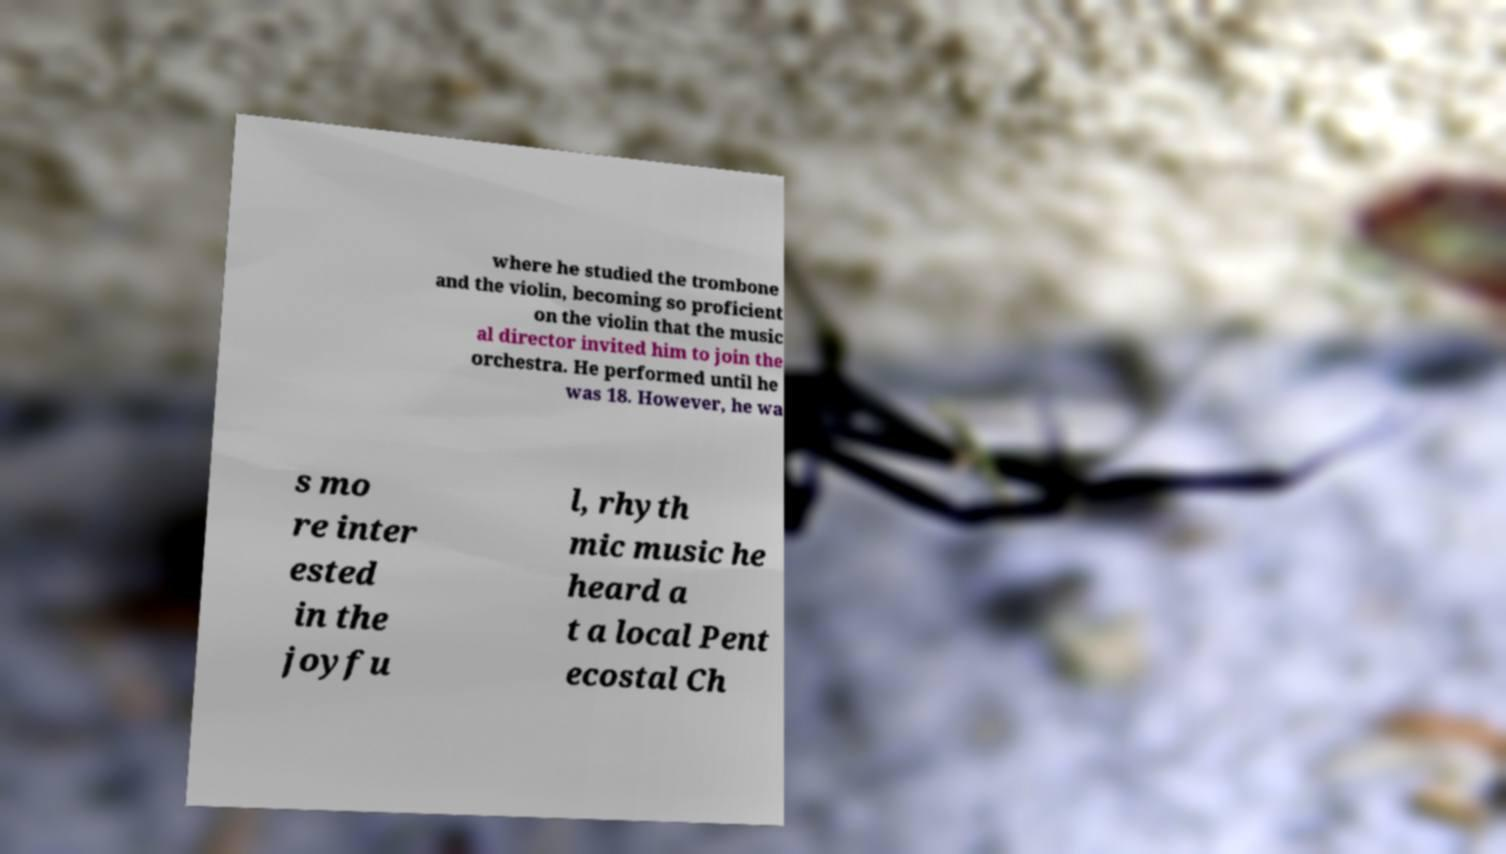Could you extract and type out the text from this image? where he studied the trombone and the violin, becoming so proficient on the violin that the music al director invited him to join the orchestra. He performed until he was 18. However, he wa s mo re inter ested in the joyfu l, rhyth mic music he heard a t a local Pent ecostal Ch 